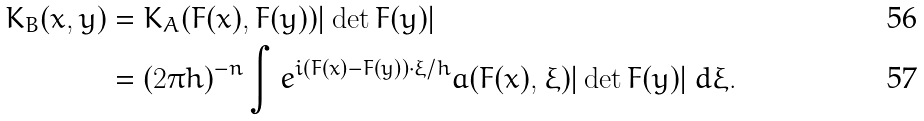<formula> <loc_0><loc_0><loc_500><loc_500>K _ { B } ( x , y ) & = K _ { A } ( F ( x ) , F ( y ) ) | \det F ( y ) | \\ & = ( 2 \pi h ) ^ { - n } \int e ^ { i ( F ( x ) - F ( y ) ) \cdot \xi / h } a ( F ( x ) , \xi ) | \det F ( y ) | \, d \xi .</formula> 